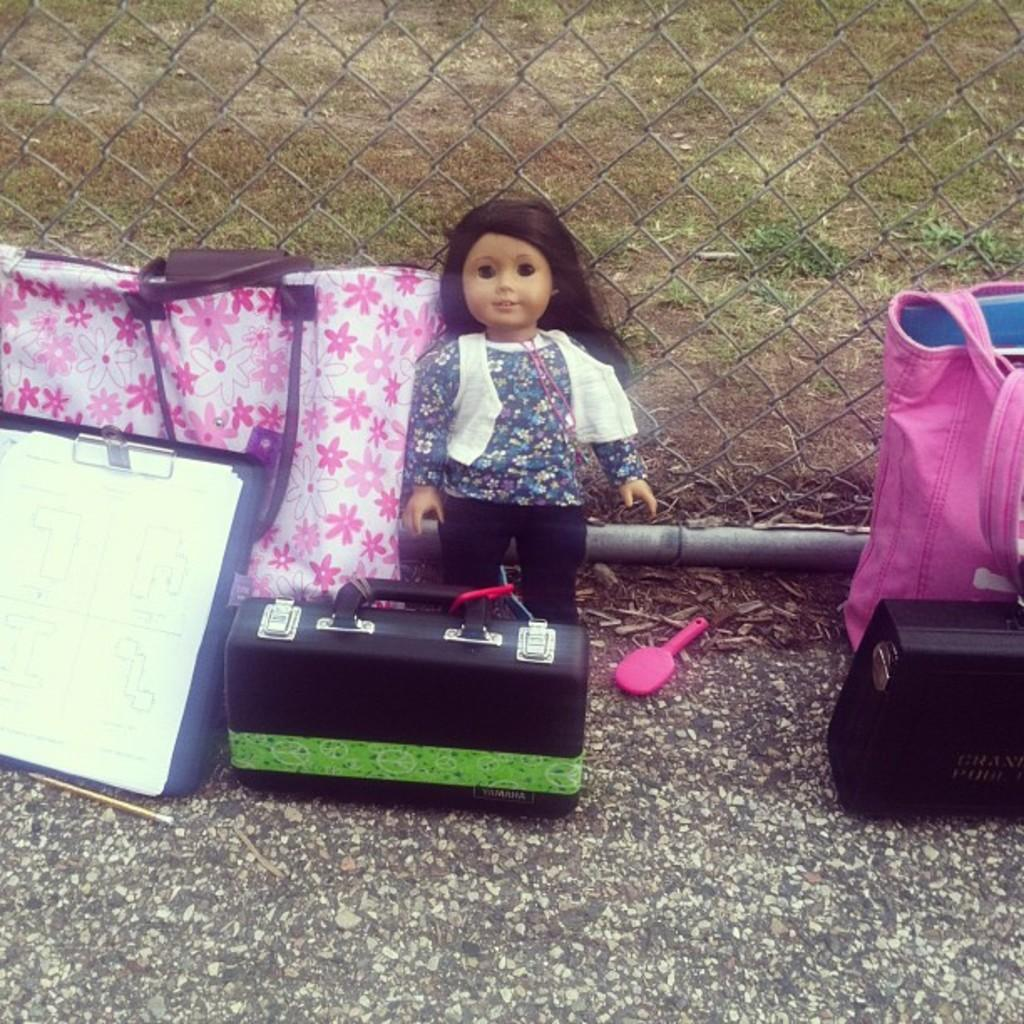What objects are on the ground in the image? There are toys on the ground in the image. What type of vegetation is present on the ground in the image? There are many grasses on the ground in the image. How many sheep are visible in the image? There are no sheep present in the image. What is the reason for the birthday celebration in the image? There is no birthday celebration depicted in the image. 